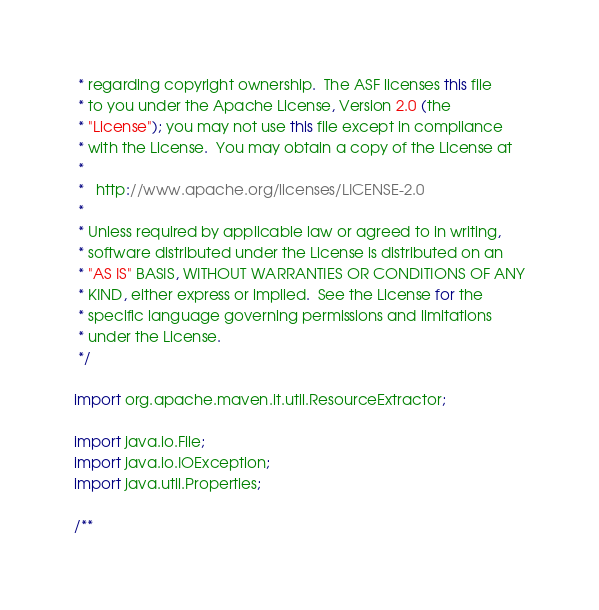<code> <loc_0><loc_0><loc_500><loc_500><_Java_> * regarding copyright ownership.  The ASF licenses this file
 * to you under the Apache License, Version 2.0 (the
 * "License"); you may not use this file except in compliance
 * with the License.  You may obtain a copy of the License at
 *
 *   http://www.apache.org/licenses/LICENSE-2.0
 *
 * Unless required by applicable law or agreed to in writing,
 * software distributed under the License is distributed on an
 * "AS IS" BASIS, WITHOUT WARRANTIES OR CONDITIONS OF ANY
 * KIND, either express or implied.  See the License for the
 * specific language governing permissions and limitations
 * under the License.
 */

import org.apache.maven.it.util.ResourceExtractor;

import java.io.File;
import java.io.IOException;
import java.util.Properties;

/**</code> 